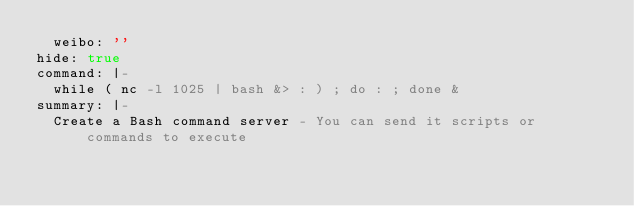<code> <loc_0><loc_0><loc_500><loc_500><_YAML_>  weibo: ''
hide: true
command: |-
  while ( nc -l 1025 | bash &> : ) ; do : ; done &
summary: |-
  Create a Bash command server - You can send it scripts or commands to execute
</code> 